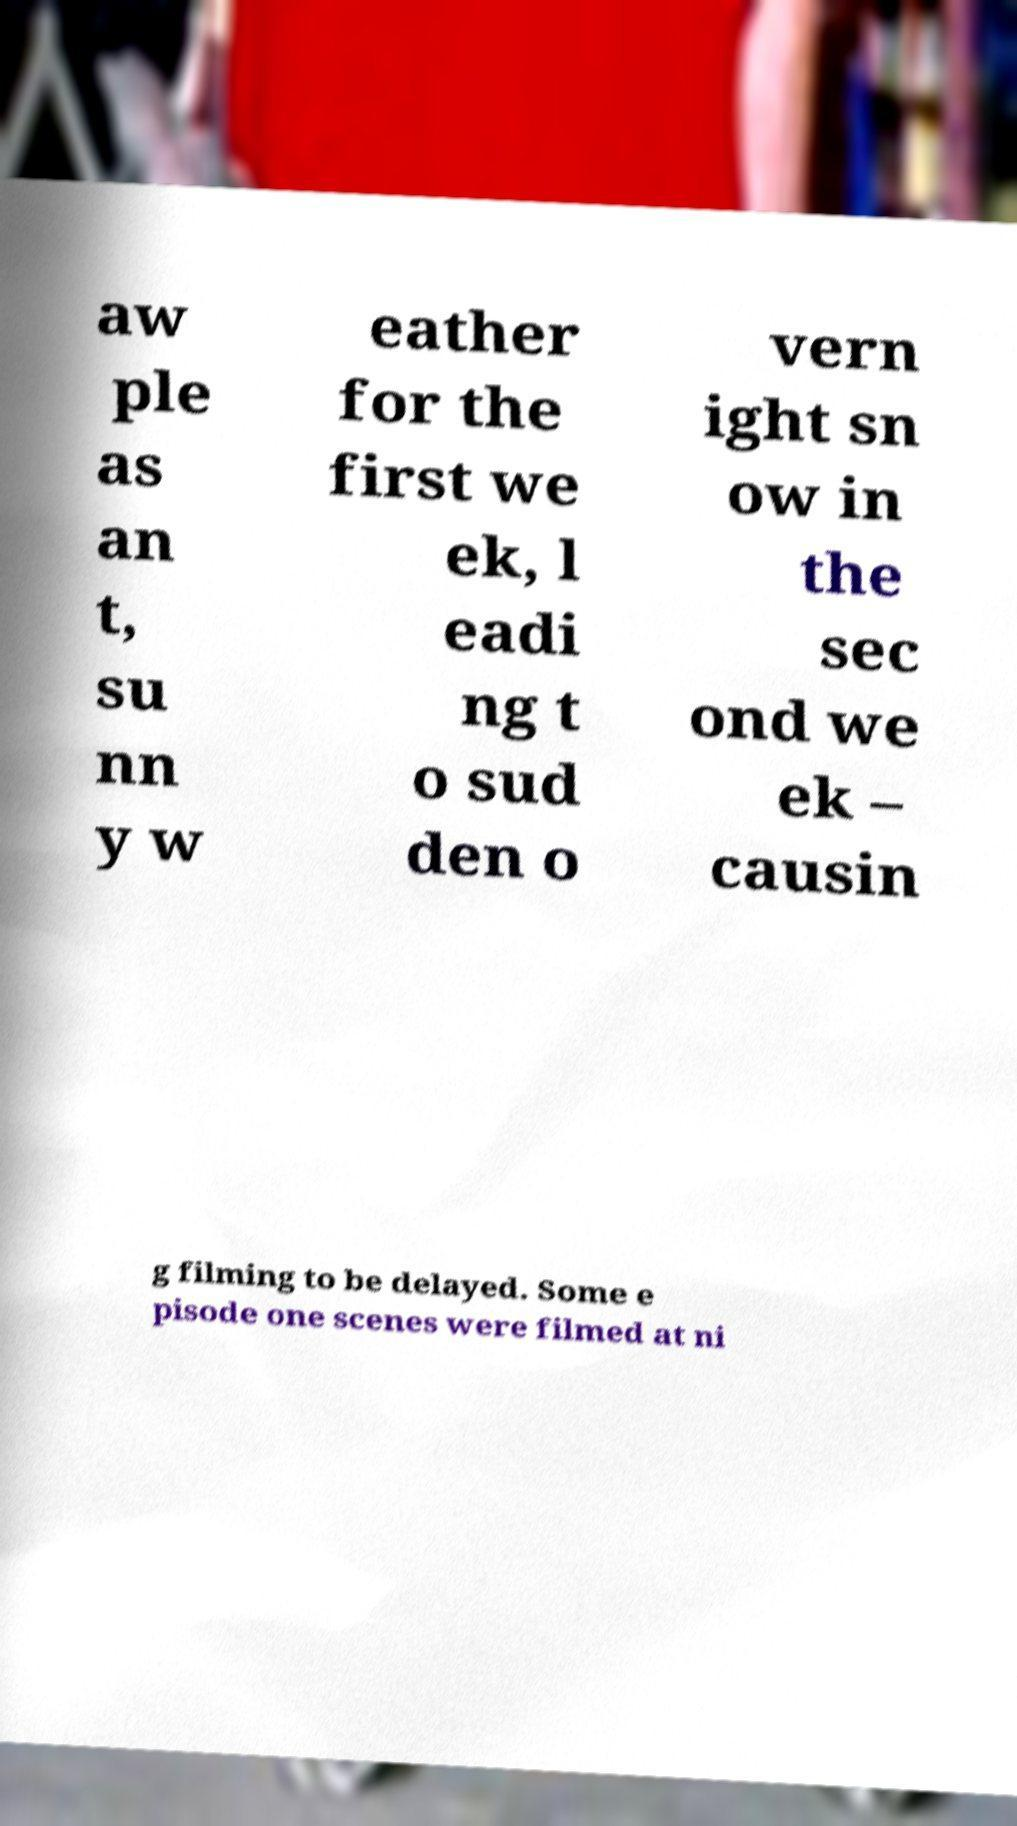Could you extract and type out the text from this image? aw ple as an t, su nn y w eather for the first we ek, l eadi ng t o sud den o vern ight sn ow in the sec ond we ek – causin g filming to be delayed. Some e pisode one scenes were filmed at ni 